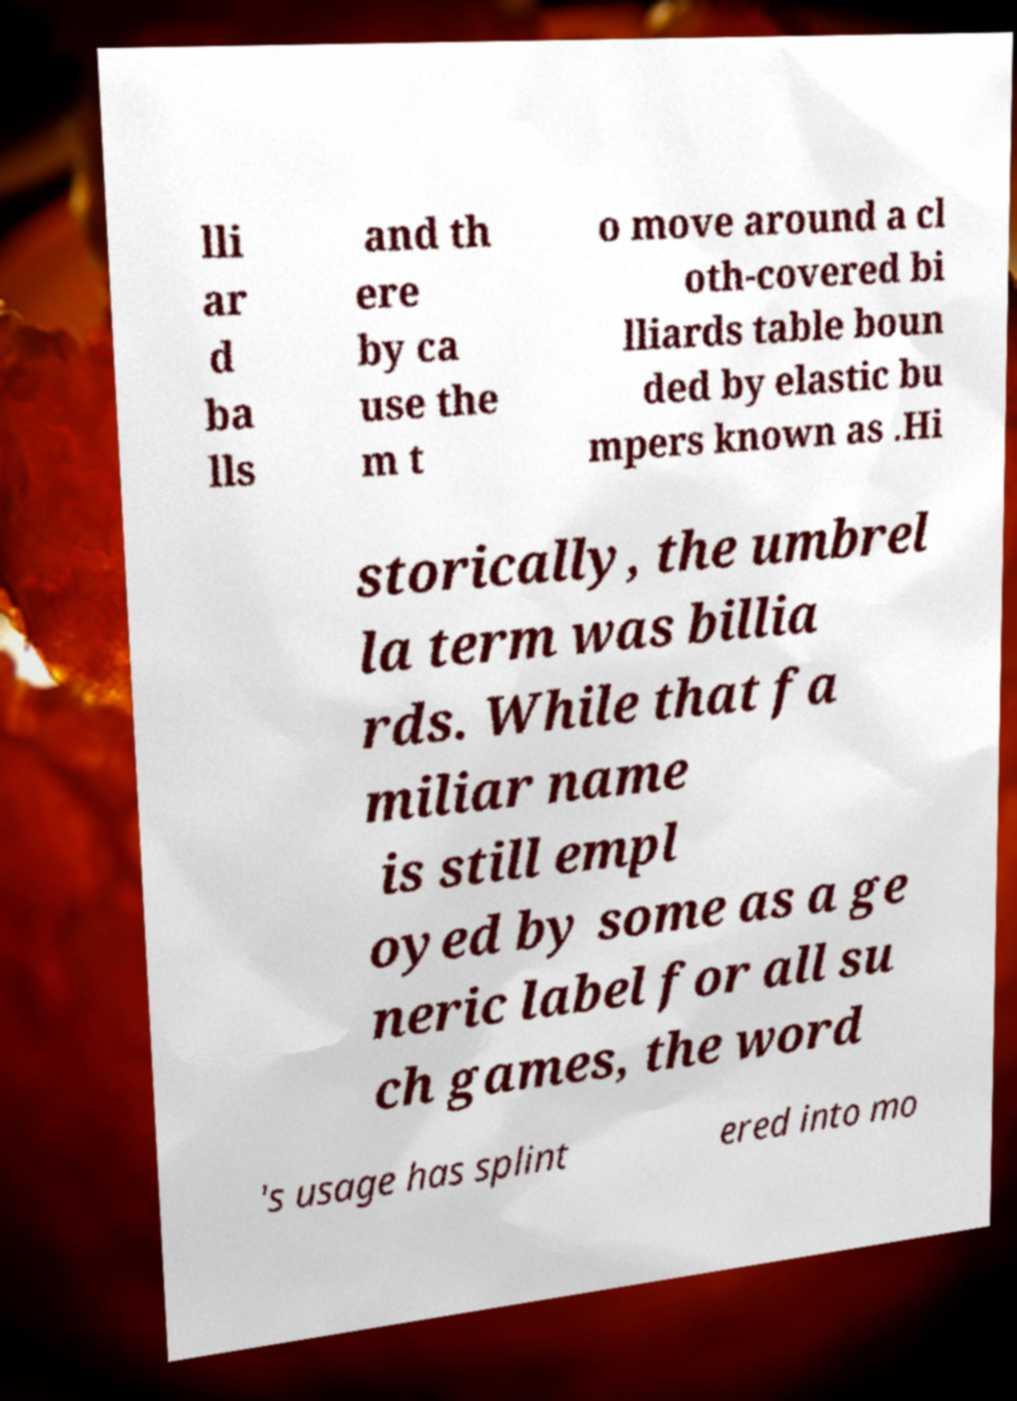I need the written content from this picture converted into text. Can you do that? lli ar d ba lls and th ere by ca use the m t o move around a cl oth-covered bi lliards table boun ded by elastic bu mpers known as .Hi storically, the umbrel la term was billia rds. While that fa miliar name is still empl oyed by some as a ge neric label for all su ch games, the word 's usage has splint ered into mo 